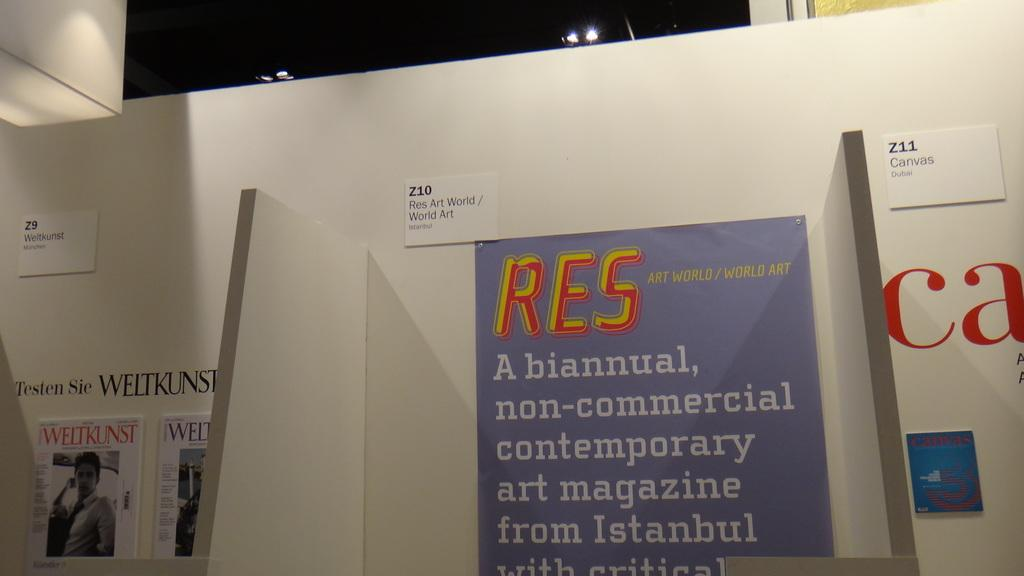<image>
Render a clear and concise summary of the photo. a wall with a paper posted on it that says 'z11 canvas dubai' 